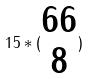<formula> <loc_0><loc_0><loc_500><loc_500>1 5 * ( \begin{matrix} 6 6 \\ 8 \end{matrix} )</formula> 